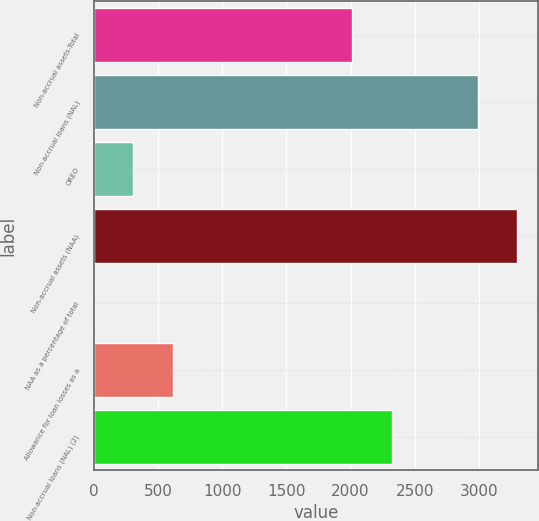<chart> <loc_0><loc_0><loc_500><loc_500><bar_chart><fcel>Non-accrual assets-Total<fcel>Non-accrual loans (NAL)<fcel>OREO<fcel>Non-accrual assets (NAA)<fcel>NAA as a percentage of total<fcel>Allowance for loan losses as a<fcel>Non-accrual loans (NAL) (2)<nl><fcel>2015<fcel>2991<fcel>306.27<fcel>3297.08<fcel>0.19<fcel>612.35<fcel>2321.08<nl></chart> 